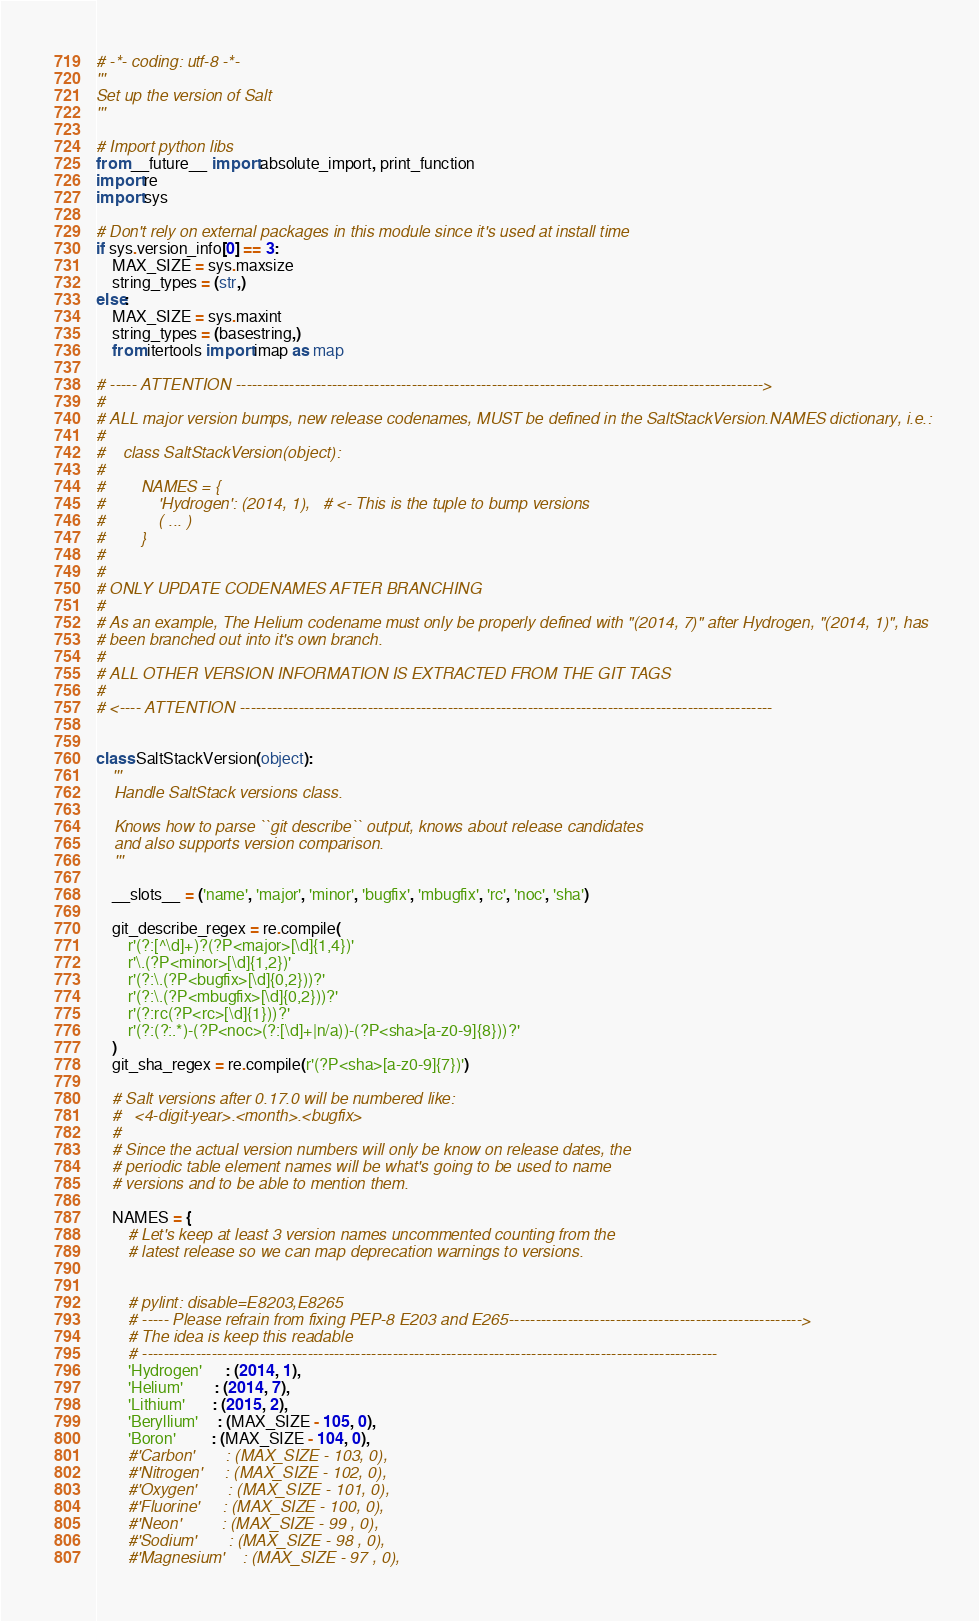<code> <loc_0><loc_0><loc_500><loc_500><_Python_># -*- coding: utf-8 -*-
'''
Set up the version of Salt
'''

# Import python libs
from __future__ import absolute_import, print_function
import re
import sys

# Don't rely on external packages in this module since it's used at install time
if sys.version_info[0] == 3:
    MAX_SIZE = sys.maxsize
    string_types = (str,)
else:
    MAX_SIZE = sys.maxint
    string_types = (basestring,)
    from itertools import imap as map

# ----- ATTENTION --------------------------------------------------------------------------------------------------->
#
# ALL major version bumps, new release codenames, MUST be defined in the SaltStackVersion.NAMES dictionary, i.e.:
#
#    class SaltStackVersion(object):
#
#        NAMES = {
#            'Hydrogen': (2014, 1),   # <- This is the tuple to bump versions
#            ( ... )
#        }
#
#
# ONLY UPDATE CODENAMES AFTER BRANCHING
#
# As an example, The Helium codename must only be properly defined with "(2014, 7)" after Hydrogen, "(2014, 1)", has
# been branched out into it's own branch.
#
# ALL OTHER VERSION INFORMATION IS EXTRACTED FROM THE GIT TAGS
#
# <---- ATTENTION ----------------------------------------------------------------------------------------------------


class SaltStackVersion(object):
    '''
    Handle SaltStack versions class.

    Knows how to parse ``git describe`` output, knows about release candidates
    and also supports version comparison.
    '''

    __slots__ = ('name', 'major', 'minor', 'bugfix', 'mbugfix', 'rc', 'noc', 'sha')

    git_describe_regex = re.compile(
        r'(?:[^\d]+)?(?P<major>[\d]{1,4})'
        r'\.(?P<minor>[\d]{1,2})'
        r'(?:\.(?P<bugfix>[\d]{0,2}))?'
        r'(?:\.(?P<mbugfix>[\d]{0,2}))?'
        r'(?:rc(?P<rc>[\d]{1}))?'
        r'(?:(?:.*)-(?P<noc>(?:[\d]+|n/a))-(?P<sha>[a-z0-9]{8}))?'
    )
    git_sha_regex = re.compile(r'(?P<sha>[a-z0-9]{7})')

    # Salt versions after 0.17.0 will be numbered like:
    #   <4-digit-year>.<month>.<bugfix>
    #
    # Since the actual version numbers will only be know on release dates, the
    # periodic table element names will be what's going to be used to name
    # versions and to be able to mention them.

    NAMES = {
        # Let's keep at least 3 version names uncommented counting from the
        # latest release so we can map deprecation warnings to versions.


        # pylint: disable=E8203,E8265
        # ----- Please refrain from fixing PEP-8 E203 and E265------------------------------------------------------->
        # The idea is keep this readable
        # ------------------------------------------------------------------------------------------------------------
        'Hydrogen'      : (2014, 1),
        'Helium'        : (2014, 7),
        'Lithium'       : (2015, 2),
        'Beryllium'     : (MAX_SIZE - 105, 0),
        'Boron'         : (MAX_SIZE - 104, 0),
        #'Carbon'       : (MAX_SIZE - 103, 0),
        #'Nitrogen'     : (MAX_SIZE - 102, 0),
        #'Oxygen'       : (MAX_SIZE - 101, 0),
        #'Fluorine'     : (MAX_SIZE - 100, 0),
        #'Neon'         : (MAX_SIZE - 99 , 0),
        #'Sodium'       : (MAX_SIZE - 98 , 0),
        #'Magnesium'    : (MAX_SIZE - 97 , 0),</code> 